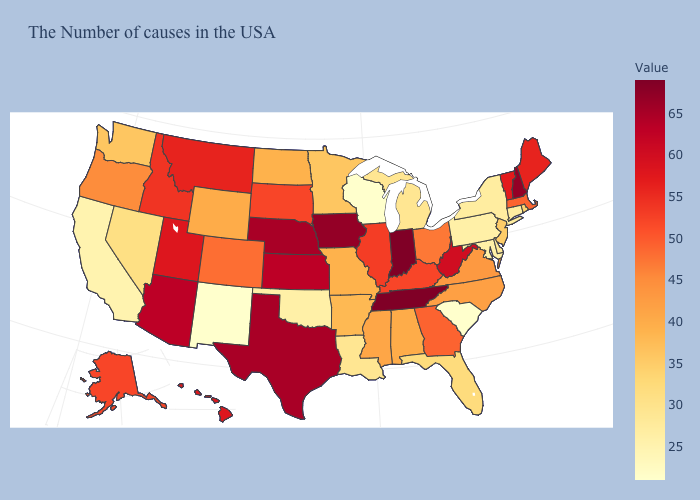Among the states that border Texas , does New Mexico have the lowest value?
Concise answer only. Yes. Which states hav the highest value in the West?
Write a very short answer. Arizona. Does Vermont have the highest value in the USA?
Give a very brief answer. No. Which states hav the highest value in the Northeast?
Keep it brief. New Hampshire. Does New Mexico have the lowest value in the West?
Write a very short answer. Yes. Among the states that border Michigan , does Indiana have the highest value?
Concise answer only. Yes. 